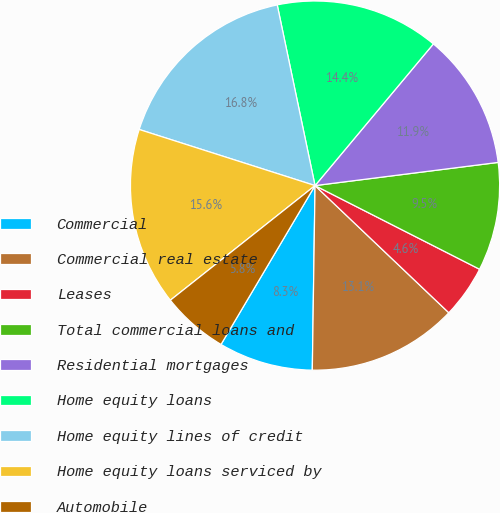<chart> <loc_0><loc_0><loc_500><loc_500><pie_chart><fcel>Commercial<fcel>Commercial real estate<fcel>Leases<fcel>Total commercial loans and<fcel>Residential mortgages<fcel>Home equity loans<fcel>Home equity lines of credit<fcel>Home equity loans serviced by<fcel>Automobile<nl><fcel>8.27%<fcel>13.14%<fcel>4.61%<fcel>9.49%<fcel>11.92%<fcel>14.36%<fcel>16.8%<fcel>15.58%<fcel>5.83%<nl></chart> 